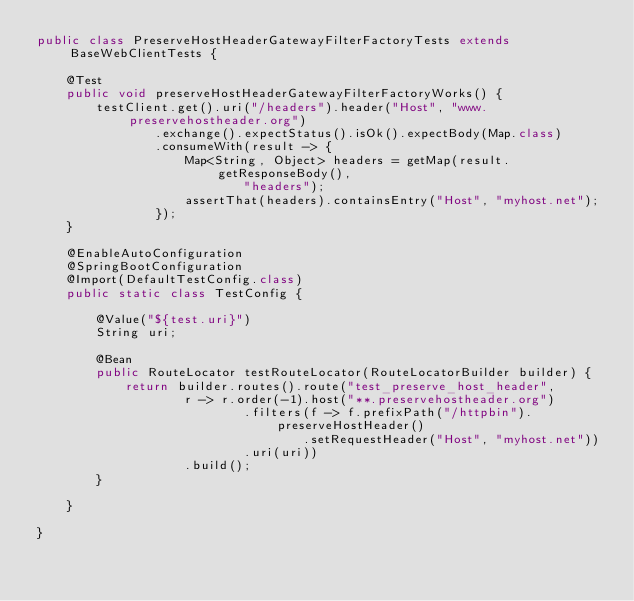Convert code to text. <code><loc_0><loc_0><loc_500><loc_500><_Java_>public class PreserveHostHeaderGatewayFilterFactoryTests extends BaseWebClientTests {

	@Test
	public void preserveHostHeaderGatewayFilterFactoryWorks() {
		testClient.get().uri("/headers").header("Host", "www.preservehostheader.org")
				.exchange().expectStatus().isOk().expectBody(Map.class)
				.consumeWith(result -> {
					Map<String, Object> headers = getMap(result.getResponseBody(),
							"headers");
					assertThat(headers).containsEntry("Host", "myhost.net");
				});
	}

	@EnableAutoConfiguration
	@SpringBootConfiguration
	@Import(DefaultTestConfig.class)
	public static class TestConfig {

		@Value("${test.uri}")
		String uri;

		@Bean
		public RouteLocator testRouteLocator(RouteLocatorBuilder builder) {
			return builder.routes().route("test_preserve_host_header",
					r -> r.order(-1).host("**.preservehostheader.org")
							.filters(f -> f.prefixPath("/httpbin").preserveHostHeader()
									.setRequestHeader("Host", "myhost.net"))
							.uri(uri))
					.build();
		}

	}

}
</code> 